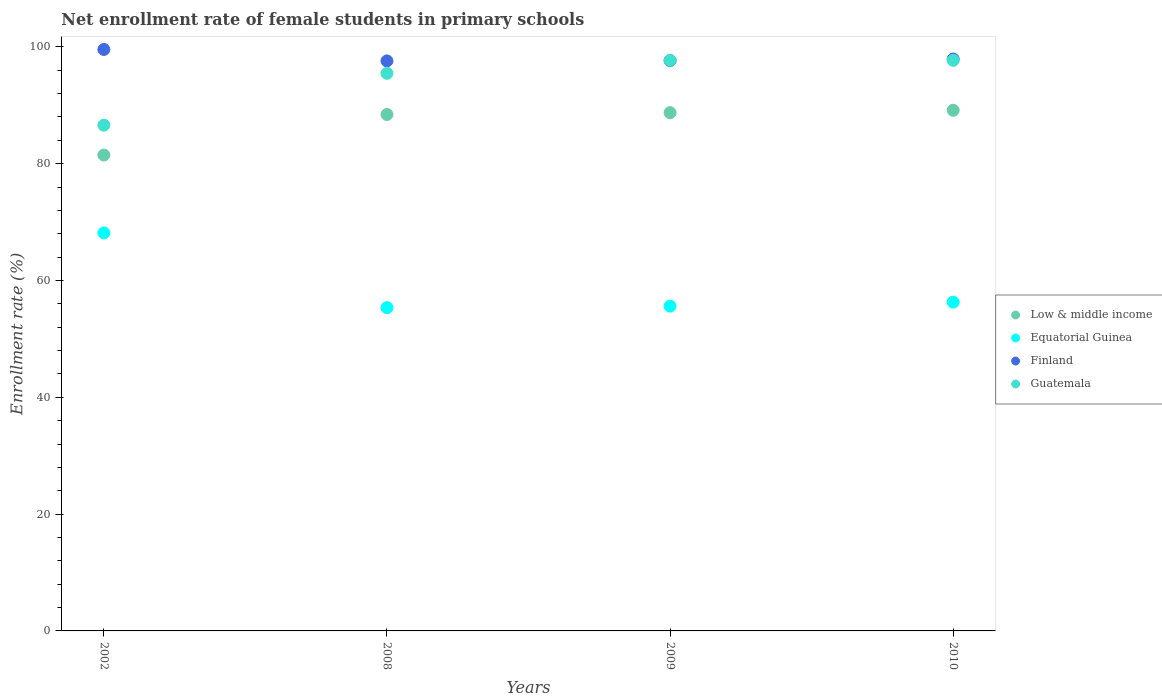How many different coloured dotlines are there?
Keep it short and to the point. 4. Is the number of dotlines equal to the number of legend labels?
Provide a succinct answer. Yes. What is the net enrollment rate of female students in primary schools in Finland in 2009?
Offer a terse response. 97.65. Across all years, what is the maximum net enrollment rate of female students in primary schools in Low & middle income?
Your response must be concise. 89.14. Across all years, what is the minimum net enrollment rate of female students in primary schools in Equatorial Guinea?
Provide a short and direct response. 55.35. What is the total net enrollment rate of female students in primary schools in Low & middle income in the graph?
Provide a succinct answer. 347.79. What is the difference between the net enrollment rate of female students in primary schools in Finland in 2008 and that in 2010?
Offer a very short reply. -0.32. What is the difference between the net enrollment rate of female students in primary schools in Low & middle income in 2008 and the net enrollment rate of female students in primary schools in Guatemala in 2009?
Provide a succinct answer. -9.28. What is the average net enrollment rate of female students in primary schools in Guatemala per year?
Make the answer very short. 94.37. In the year 2010, what is the difference between the net enrollment rate of female students in primary schools in Equatorial Guinea and net enrollment rate of female students in primary schools in Guatemala?
Your answer should be very brief. -41.4. In how many years, is the net enrollment rate of female students in primary schools in Equatorial Guinea greater than 52 %?
Make the answer very short. 4. What is the ratio of the net enrollment rate of female students in primary schools in Guatemala in 2009 to that in 2010?
Your answer should be very brief. 1. What is the difference between the highest and the second highest net enrollment rate of female students in primary schools in Finland?
Keep it short and to the point. 1.63. What is the difference between the highest and the lowest net enrollment rate of female students in primary schools in Guatemala?
Give a very brief answer. 11.11. In how many years, is the net enrollment rate of female students in primary schools in Guatemala greater than the average net enrollment rate of female students in primary schools in Guatemala taken over all years?
Your response must be concise. 3. Is the sum of the net enrollment rate of female students in primary schools in Finland in 2002 and 2010 greater than the maximum net enrollment rate of female students in primary schools in Guatemala across all years?
Keep it short and to the point. Yes. Is it the case that in every year, the sum of the net enrollment rate of female students in primary schools in Guatemala and net enrollment rate of female students in primary schools in Equatorial Guinea  is greater than the sum of net enrollment rate of female students in primary schools in Finland and net enrollment rate of female students in primary schools in Low & middle income?
Make the answer very short. No. Is it the case that in every year, the sum of the net enrollment rate of female students in primary schools in Finland and net enrollment rate of female students in primary schools in Low & middle income  is greater than the net enrollment rate of female students in primary schools in Equatorial Guinea?
Ensure brevity in your answer.  Yes. Is the net enrollment rate of female students in primary schools in Guatemala strictly less than the net enrollment rate of female students in primary schools in Equatorial Guinea over the years?
Offer a very short reply. No. How many dotlines are there?
Ensure brevity in your answer.  4. What is the difference between two consecutive major ticks on the Y-axis?
Give a very brief answer. 20. Does the graph contain any zero values?
Your response must be concise. No. Does the graph contain grids?
Your response must be concise. No. How are the legend labels stacked?
Keep it short and to the point. Vertical. What is the title of the graph?
Offer a very short reply. Net enrollment rate of female students in primary schools. Does "Togo" appear as one of the legend labels in the graph?
Your response must be concise. No. What is the label or title of the X-axis?
Offer a terse response. Years. What is the label or title of the Y-axis?
Make the answer very short. Enrollment rate (%). What is the Enrollment rate (%) of Low & middle income in 2002?
Your answer should be very brief. 81.48. What is the Enrollment rate (%) of Equatorial Guinea in 2002?
Your answer should be compact. 68.15. What is the Enrollment rate (%) of Finland in 2002?
Give a very brief answer. 99.55. What is the Enrollment rate (%) in Guatemala in 2002?
Provide a short and direct response. 86.59. What is the Enrollment rate (%) of Low & middle income in 2008?
Ensure brevity in your answer.  88.43. What is the Enrollment rate (%) in Equatorial Guinea in 2008?
Make the answer very short. 55.35. What is the Enrollment rate (%) in Finland in 2008?
Keep it short and to the point. 97.6. What is the Enrollment rate (%) in Guatemala in 2008?
Provide a succinct answer. 95.47. What is the Enrollment rate (%) in Low & middle income in 2009?
Your response must be concise. 88.74. What is the Enrollment rate (%) of Equatorial Guinea in 2009?
Your response must be concise. 55.61. What is the Enrollment rate (%) in Finland in 2009?
Your response must be concise. 97.65. What is the Enrollment rate (%) of Guatemala in 2009?
Ensure brevity in your answer.  97.7. What is the Enrollment rate (%) of Low & middle income in 2010?
Provide a succinct answer. 89.14. What is the Enrollment rate (%) of Equatorial Guinea in 2010?
Make the answer very short. 56.29. What is the Enrollment rate (%) of Finland in 2010?
Provide a succinct answer. 97.92. What is the Enrollment rate (%) of Guatemala in 2010?
Make the answer very short. 97.69. Across all years, what is the maximum Enrollment rate (%) of Low & middle income?
Provide a short and direct response. 89.14. Across all years, what is the maximum Enrollment rate (%) of Equatorial Guinea?
Offer a very short reply. 68.15. Across all years, what is the maximum Enrollment rate (%) of Finland?
Your answer should be compact. 99.55. Across all years, what is the maximum Enrollment rate (%) of Guatemala?
Keep it short and to the point. 97.7. Across all years, what is the minimum Enrollment rate (%) in Low & middle income?
Your answer should be compact. 81.48. Across all years, what is the minimum Enrollment rate (%) of Equatorial Guinea?
Your answer should be compact. 55.35. Across all years, what is the minimum Enrollment rate (%) of Finland?
Give a very brief answer. 97.6. Across all years, what is the minimum Enrollment rate (%) in Guatemala?
Provide a short and direct response. 86.59. What is the total Enrollment rate (%) of Low & middle income in the graph?
Offer a very short reply. 347.79. What is the total Enrollment rate (%) of Equatorial Guinea in the graph?
Give a very brief answer. 235.4. What is the total Enrollment rate (%) in Finland in the graph?
Give a very brief answer. 392.72. What is the total Enrollment rate (%) of Guatemala in the graph?
Your answer should be very brief. 377.47. What is the difference between the Enrollment rate (%) of Low & middle income in 2002 and that in 2008?
Give a very brief answer. -6.94. What is the difference between the Enrollment rate (%) in Equatorial Guinea in 2002 and that in 2008?
Keep it short and to the point. 12.79. What is the difference between the Enrollment rate (%) of Finland in 2002 and that in 2008?
Your answer should be compact. 1.96. What is the difference between the Enrollment rate (%) of Guatemala in 2002 and that in 2008?
Offer a terse response. -8.88. What is the difference between the Enrollment rate (%) in Low & middle income in 2002 and that in 2009?
Give a very brief answer. -7.25. What is the difference between the Enrollment rate (%) in Equatorial Guinea in 2002 and that in 2009?
Offer a terse response. 12.54. What is the difference between the Enrollment rate (%) of Finland in 2002 and that in 2009?
Offer a very short reply. 1.9. What is the difference between the Enrollment rate (%) of Guatemala in 2002 and that in 2009?
Ensure brevity in your answer.  -11.11. What is the difference between the Enrollment rate (%) of Low & middle income in 2002 and that in 2010?
Provide a short and direct response. -7.66. What is the difference between the Enrollment rate (%) in Equatorial Guinea in 2002 and that in 2010?
Give a very brief answer. 11.85. What is the difference between the Enrollment rate (%) of Finland in 2002 and that in 2010?
Your answer should be compact. 1.63. What is the difference between the Enrollment rate (%) of Guatemala in 2002 and that in 2010?
Your answer should be very brief. -11.1. What is the difference between the Enrollment rate (%) in Low & middle income in 2008 and that in 2009?
Your answer should be compact. -0.31. What is the difference between the Enrollment rate (%) in Equatorial Guinea in 2008 and that in 2009?
Your response must be concise. -0.26. What is the difference between the Enrollment rate (%) in Finland in 2008 and that in 2009?
Your answer should be very brief. -0.05. What is the difference between the Enrollment rate (%) in Guatemala in 2008 and that in 2009?
Ensure brevity in your answer.  -2.23. What is the difference between the Enrollment rate (%) in Low & middle income in 2008 and that in 2010?
Offer a terse response. -0.71. What is the difference between the Enrollment rate (%) of Equatorial Guinea in 2008 and that in 2010?
Your answer should be compact. -0.94. What is the difference between the Enrollment rate (%) of Finland in 2008 and that in 2010?
Keep it short and to the point. -0.32. What is the difference between the Enrollment rate (%) of Guatemala in 2008 and that in 2010?
Make the answer very short. -2.22. What is the difference between the Enrollment rate (%) of Low & middle income in 2009 and that in 2010?
Your answer should be very brief. -0.41. What is the difference between the Enrollment rate (%) of Equatorial Guinea in 2009 and that in 2010?
Your response must be concise. -0.68. What is the difference between the Enrollment rate (%) in Finland in 2009 and that in 2010?
Keep it short and to the point. -0.27. What is the difference between the Enrollment rate (%) of Guatemala in 2009 and that in 2010?
Provide a short and direct response. 0.01. What is the difference between the Enrollment rate (%) of Low & middle income in 2002 and the Enrollment rate (%) of Equatorial Guinea in 2008?
Provide a succinct answer. 26.13. What is the difference between the Enrollment rate (%) of Low & middle income in 2002 and the Enrollment rate (%) of Finland in 2008?
Ensure brevity in your answer.  -16.11. What is the difference between the Enrollment rate (%) of Low & middle income in 2002 and the Enrollment rate (%) of Guatemala in 2008?
Offer a terse response. -13.99. What is the difference between the Enrollment rate (%) of Equatorial Guinea in 2002 and the Enrollment rate (%) of Finland in 2008?
Offer a terse response. -29.45. What is the difference between the Enrollment rate (%) of Equatorial Guinea in 2002 and the Enrollment rate (%) of Guatemala in 2008?
Keep it short and to the point. -27.33. What is the difference between the Enrollment rate (%) of Finland in 2002 and the Enrollment rate (%) of Guatemala in 2008?
Your answer should be compact. 4.08. What is the difference between the Enrollment rate (%) in Low & middle income in 2002 and the Enrollment rate (%) in Equatorial Guinea in 2009?
Make the answer very short. 25.87. What is the difference between the Enrollment rate (%) in Low & middle income in 2002 and the Enrollment rate (%) in Finland in 2009?
Keep it short and to the point. -16.17. What is the difference between the Enrollment rate (%) of Low & middle income in 2002 and the Enrollment rate (%) of Guatemala in 2009?
Ensure brevity in your answer.  -16.22. What is the difference between the Enrollment rate (%) in Equatorial Guinea in 2002 and the Enrollment rate (%) in Finland in 2009?
Your answer should be compact. -29.51. What is the difference between the Enrollment rate (%) of Equatorial Guinea in 2002 and the Enrollment rate (%) of Guatemala in 2009?
Offer a terse response. -29.56. What is the difference between the Enrollment rate (%) in Finland in 2002 and the Enrollment rate (%) in Guatemala in 2009?
Provide a succinct answer. 1.85. What is the difference between the Enrollment rate (%) of Low & middle income in 2002 and the Enrollment rate (%) of Equatorial Guinea in 2010?
Your answer should be very brief. 25.19. What is the difference between the Enrollment rate (%) of Low & middle income in 2002 and the Enrollment rate (%) of Finland in 2010?
Make the answer very short. -16.44. What is the difference between the Enrollment rate (%) of Low & middle income in 2002 and the Enrollment rate (%) of Guatemala in 2010?
Make the answer very short. -16.21. What is the difference between the Enrollment rate (%) of Equatorial Guinea in 2002 and the Enrollment rate (%) of Finland in 2010?
Ensure brevity in your answer.  -29.77. What is the difference between the Enrollment rate (%) in Equatorial Guinea in 2002 and the Enrollment rate (%) in Guatemala in 2010?
Your answer should be very brief. -29.55. What is the difference between the Enrollment rate (%) in Finland in 2002 and the Enrollment rate (%) in Guatemala in 2010?
Your answer should be very brief. 1.86. What is the difference between the Enrollment rate (%) of Low & middle income in 2008 and the Enrollment rate (%) of Equatorial Guinea in 2009?
Make the answer very short. 32.82. What is the difference between the Enrollment rate (%) in Low & middle income in 2008 and the Enrollment rate (%) in Finland in 2009?
Ensure brevity in your answer.  -9.22. What is the difference between the Enrollment rate (%) of Low & middle income in 2008 and the Enrollment rate (%) of Guatemala in 2009?
Provide a short and direct response. -9.28. What is the difference between the Enrollment rate (%) of Equatorial Guinea in 2008 and the Enrollment rate (%) of Finland in 2009?
Offer a terse response. -42.3. What is the difference between the Enrollment rate (%) of Equatorial Guinea in 2008 and the Enrollment rate (%) of Guatemala in 2009?
Your answer should be very brief. -42.35. What is the difference between the Enrollment rate (%) in Finland in 2008 and the Enrollment rate (%) in Guatemala in 2009?
Your response must be concise. -0.11. What is the difference between the Enrollment rate (%) in Low & middle income in 2008 and the Enrollment rate (%) in Equatorial Guinea in 2010?
Ensure brevity in your answer.  32.14. What is the difference between the Enrollment rate (%) of Low & middle income in 2008 and the Enrollment rate (%) of Finland in 2010?
Provide a short and direct response. -9.49. What is the difference between the Enrollment rate (%) in Low & middle income in 2008 and the Enrollment rate (%) in Guatemala in 2010?
Your answer should be compact. -9.27. What is the difference between the Enrollment rate (%) in Equatorial Guinea in 2008 and the Enrollment rate (%) in Finland in 2010?
Provide a succinct answer. -42.57. What is the difference between the Enrollment rate (%) of Equatorial Guinea in 2008 and the Enrollment rate (%) of Guatemala in 2010?
Your answer should be compact. -42.34. What is the difference between the Enrollment rate (%) of Finland in 2008 and the Enrollment rate (%) of Guatemala in 2010?
Offer a very short reply. -0.1. What is the difference between the Enrollment rate (%) in Low & middle income in 2009 and the Enrollment rate (%) in Equatorial Guinea in 2010?
Your response must be concise. 32.44. What is the difference between the Enrollment rate (%) of Low & middle income in 2009 and the Enrollment rate (%) of Finland in 2010?
Provide a succinct answer. -9.19. What is the difference between the Enrollment rate (%) of Low & middle income in 2009 and the Enrollment rate (%) of Guatemala in 2010?
Provide a short and direct response. -8.96. What is the difference between the Enrollment rate (%) in Equatorial Guinea in 2009 and the Enrollment rate (%) in Finland in 2010?
Give a very brief answer. -42.31. What is the difference between the Enrollment rate (%) of Equatorial Guinea in 2009 and the Enrollment rate (%) of Guatemala in 2010?
Keep it short and to the point. -42.09. What is the difference between the Enrollment rate (%) of Finland in 2009 and the Enrollment rate (%) of Guatemala in 2010?
Ensure brevity in your answer.  -0.04. What is the average Enrollment rate (%) of Low & middle income per year?
Your answer should be compact. 86.95. What is the average Enrollment rate (%) of Equatorial Guinea per year?
Provide a short and direct response. 58.85. What is the average Enrollment rate (%) in Finland per year?
Make the answer very short. 98.18. What is the average Enrollment rate (%) in Guatemala per year?
Ensure brevity in your answer.  94.37. In the year 2002, what is the difference between the Enrollment rate (%) of Low & middle income and Enrollment rate (%) of Equatorial Guinea?
Your answer should be compact. 13.34. In the year 2002, what is the difference between the Enrollment rate (%) of Low & middle income and Enrollment rate (%) of Finland?
Your answer should be very brief. -18.07. In the year 2002, what is the difference between the Enrollment rate (%) in Low & middle income and Enrollment rate (%) in Guatemala?
Offer a terse response. -5.11. In the year 2002, what is the difference between the Enrollment rate (%) in Equatorial Guinea and Enrollment rate (%) in Finland?
Offer a terse response. -31.41. In the year 2002, what is the difference between the Enrollment rate (%) in Equatorial Guinea and Enrollment rate (%) in Guatemala?
Provide a succinct answer. -18.45. In the year 2002, what is the difference between the Enrollment rate (%) in Finland and Enrollment rate (%) in Guatemala?
Give a very brief answer. 12.96. In the year 2008, what is the difference between the Enrollment rate (%) in Low & middle income and Enrollment rate (%) in Equatorial Guinea?
Your response must be concise. 33.08. In the year 2008, what is the difference between the Enrollment rate (%) in Low & middle income and Enrollment rate (%) in Finland?
Keep it short and to the point. -9.17. In the year 2008, what is the difference between the Enrollment rate (%) of Low & middle income and Enrollment rate (%) of Guatemala?
Your response must be concise. -7.05. In the year 2008, what is the difference between the Enrollment rate (%) in Equatorial Guinea and Enrollment rate (%) in Finland?
Your answer should be very brief. -42.24. In the year 2008, what is the difference between the Enrollment rate (%) of Equatorial Guinea and Enrollment rate (%) of Guatemala?
Ensure brevity in your answer.  -40.12. In the year 2008, what is the difference between the Enrollment rate (%) of Finland and Enrollment rate (%) of Guatemala?
Your answer should be compact. 2.12. In the year 2009, what is the difference between the Enrollment rate (%) in Low & middle income and Enrollment rate (%) in Equatorial Guinea?
Ensure brevity in your answer.  33.13. In the year 2009, what is the difference between the Enrollment rate (%) in Low & middle income and Enrollment rate (%) in Finland?
Your answer should be very brief. -8.92. In the year 2009, what is the difference between the Enrollment rate (%) of Low & middle income and Enrollment rate (%) of Guatemala?
Provide a succinct answer. -8.97. In the year 2009, what is the difference between the Enrollment rate (%) in Equatorial Guinea and Enrollment rate (%) in Finland?
Give a very brief answer. -42.04. In the year 2009, what is the difference between the Enrollment rate (%) of Equatorial Guinea and Enrollment rate (%) of Guatemala?
Provide a short and direct response. -42.1. In the year 2009, what is the difference between the Enrollment rate (%) of Finland and Enrollment rate (%) of Guatemala?
Provide a short and direct response. -0.05. In the year 2010, what is the difference between the Enrollment rate (%) of Low & middle income and Enrollment rate (%) of Equatorial Guinea?
Provide a succinct answer. 32.85. In the year 2010, what is the difference between the Enrollment rate (%) of Low & middle income and Enrollment rate (%) of Finland?
Your response must be concise. -8.78. In the year 2010, what is the difference between the Enrollment rate (%) of Low & middle income and Enrollment rate (%) of Guatemala?
Keep it short and to the point. -8.55. In the year 2010, what is the difference between the Enrollment rate (%) of Equatorial Guinea and Enrollment rate (%) of Finland?
Provide a succinct answer. -41.63. In the year 2010, what is the difference between the Enrollment rate (%) of Equatorial Guinea and Enrollment rate (%) of Guatemala?
Provide a short and direct response. -41.4. In the year 2010, what is the difference between the Enrollment rate (%) of Finland and Enrollment rate (%) of Guatemala?
Ensure brevity in your answer.  0.23. What is the ratio of the Enrollment rate (%) in Low & middle income in 2002 to that in 2008?
Provide a succinct answer. 0.92. What is the ratio of the Enrollment rate (%) in Equatorial Guinea in 2002 to that in 2008?
Your response must be concise. 1.23. What is the ratio of the Enrollment rate (%) of Finland in 2002 to that in 2008?
Give a very brief answer. 1.02. What is the ratio of the Enrollment rate (%) of Guatemala in 2002 to that in 2008?
Your response must be concise. 0.91. What is the ratio of the Enrollment rate (%) in Low & middle income in 2002 to that in 2009?
Your answer should be very brief. 0.92. What is the ratio of the Enrollment rate (%) in Equatorial Guinea in 2002 to that in 2009?
Your answer should be compact. 1.23. What is the ratio of the Enrollment rate (%) in Finland in 2002 to that in 2009?
Give a very brief answer. 1.02. What is the ratio of the Enrollment rate (%) in Guatemala in 2002 to that in 2009?
Ensure brevity in your answer.  0.89. What is the ratio of the Enrollment rate (%) in Low & middle income in 2002 to that in 2010?
Offer a terse response. 0.91. What is the ratio of the Enrollment rate (%) in Equatorial Guinea in 2002 to that in 2010?
Offer a terse response. 1.21. What is the ratio of the Enrollment rate (%) of Finland in 2002 to that in 2010?
Give a very brief answer. 1.02. What is the ratio of the Enrollment rate (%) of Guatemala in 2002 to that in 2010?
Offer a terse response. 0.89. What is the ratio of the Enrollment rate (%) in Equatorial Guinea in 2008 to that in 2009?
Your answer should be compact. 1. What is the ratio of the Enrollment rate (%) in Guatemala in 2008 to that in 2009?
Your response must be concise. 0.98. What is the ratio of the Enrollment rate (%) of Equatorial Guinea in 2008 to that in 2010?
Offer a very short reply. 0.98. What is the ratio of the Enrollment rate (%) in Guatemala in 2008 to that in 2010?
Offer a terse response. 0.98. What is the ratio of the Enrollment rate (%) of Low & middle income in 2009 to that in 2010?
Offer a terse response. 1. What is the ratio of the Enrollment rate (%) in Equatorial Guinea in 2009 to that in 2010?
Ensure brevity in your answer.  0.99. What is the ratio of the Enrollment rate (%) in Finland in 2009 to that in 2010?
Offer a very short reply. 1. What is the difference between the highest and the second highest Enrollment rate (%) of Low & middle income?
Keep it short and to the point. 0.41. What is the difference between the highest and the second highest Enrollment rate (%) of Equatorial Guinea?
Provide a succinct answer. 11.85. What is the difference between the highest and the second highest Enrollment rate (%) of Finland?
Provide a succinct answer. 1.63. What is the difference between the highest and the second highest Enrollment rate (%) of Guatemala?
Your response must be concise. 0.01. What is the difference between the highest and the lowest Enrollment rate (%) of Low & middle income?
Offer a very short reply. 7.66. What is the difference between the highest and the lowest Enrollment rate (%) of Equatorial Guinea?
Give a very brief answer. 12.79. What is the difference between the highest and the lowest Enrollment rate (%) in Finland?
Provide a succinct answer. 1.96. What is the difference between the highest and the lowest Enrollment rate (%) of Guatemala?
Your response must be concise. 11.11. 